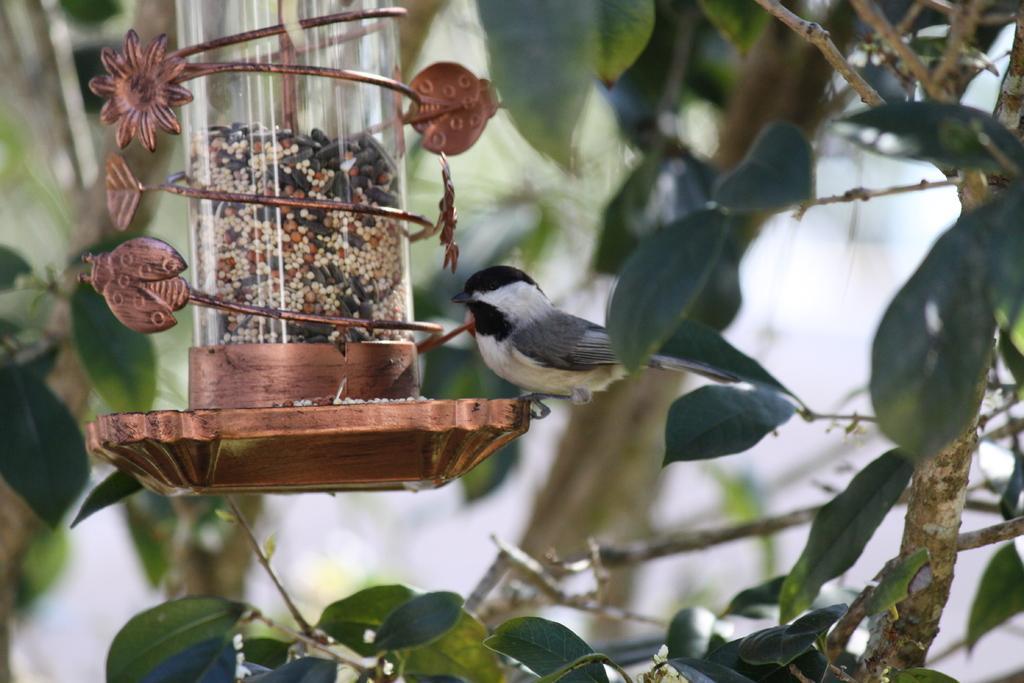Can you describe this image briefly? There is one bird sitting on a bird feeder as we can see on the left side of this image ,and there is a stem with some leaves in the background. 